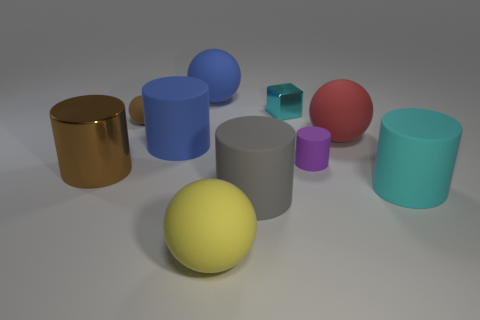Subtract all cyan cylinders. How many cylinders are left? 4 Subtract 1 spheres. How many spheres are left? 3 Subtract all big metal cylinders. How many cylinders are left? 4 Subtract all green cylinders. Subtract all yellow balls. How many cylinders are left? 5 Subtract all blocks. How many objects are left? 9 Add 2 small matte cylinders. How many small matte cylinders are left? 3 Add 3 red matte objects. How many red matte objects exist? 4 Subtract 1 brown spheres. How many objects are left? 9 Subtract all large yellow cylinders. Subtract all shiny things. How many objects are left? 8 